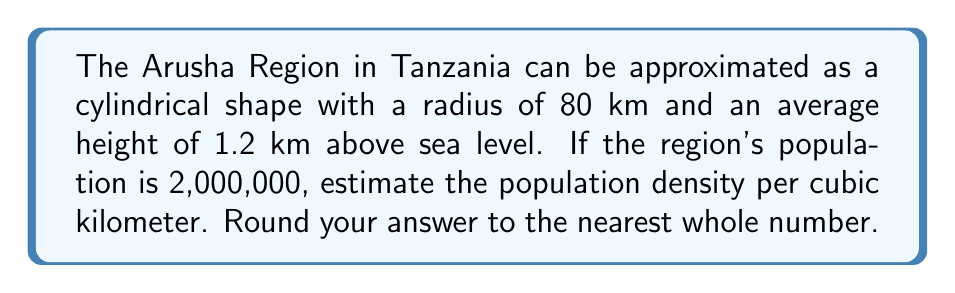Teach me how to tackle this problem. To solve this problem, we need to follow these steps:

1. Calculate the volume of the cylindrical region
2. Convert the volume to cubic kilometers
3. Calculate the population density

Step 1: Calculate the volume of the cylindrical region

The formula for the volume of a cylinder is:

$$V = \pi r^2 h$$

Where:
$r$ = radius
$h$ = height

Substituting the given values:

$$V = \pi (80 \text{ km})^2 (1.2 \text{ km})$$
$$V = \pi (6400 \text{ km}^2) (1.2 \text{ km})$$
$$V = 7680\pi \text{ km}^3$$

Step 2: Convert the volume to cubic kilometers

$$V = 7680\pi \text{ km}^3 \approx 24,127.43 \text{ km}^3$$

Step 3: Calculate the population density

Population density is calculated by dividing the total population by the volume:

$$\text{Population Density} = \frac{\text{Total Population}}{\text{Volume}}$$

Substituting the values:

$$\text{Population Density} = \frac{2,000,000}{24,127.43 \text{ km}^3}$$
$$\text{Population Density} \approx 82.89 \text{ people/km}^3$$

Rounding to the nearest whole number:

$$\text{Population Density} \approx 83 \text{ people/km}^3$$
Answer: 83 people/km³ 